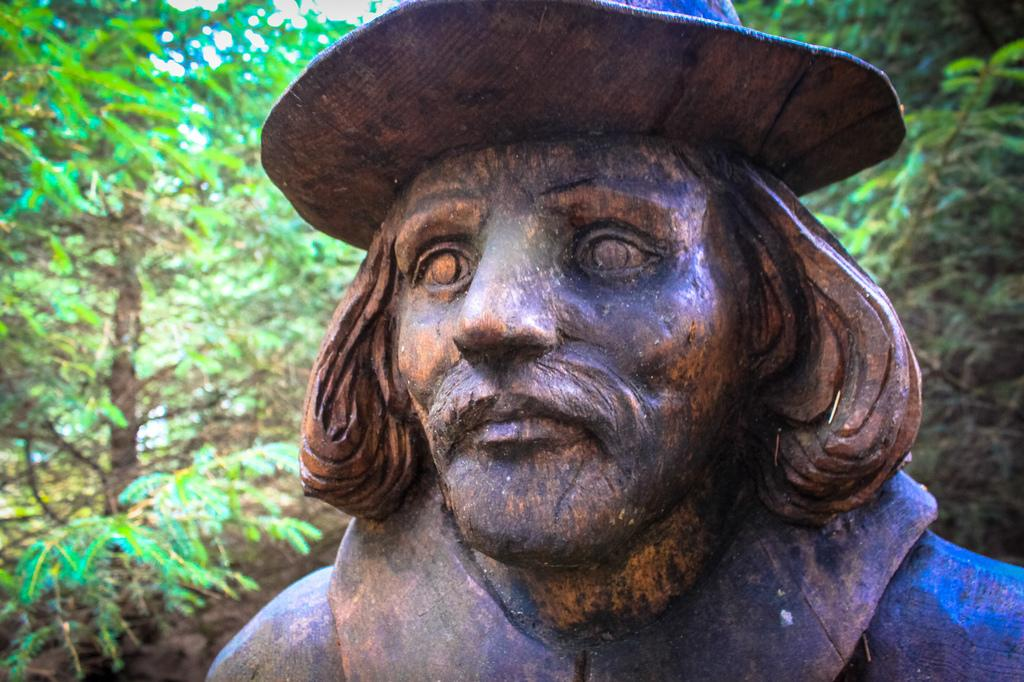What is the main subject in the image? There is a person statue in the image. What can be seen in the background of the image? There are trees in the background of the image. What is the color of the trees in the image? The trees are green in color. How many minutes does it take for the ship to pass by in the image? There is no ship present in the image, so it is not possible to determine how many minutes it would take for a ship to pass by. 